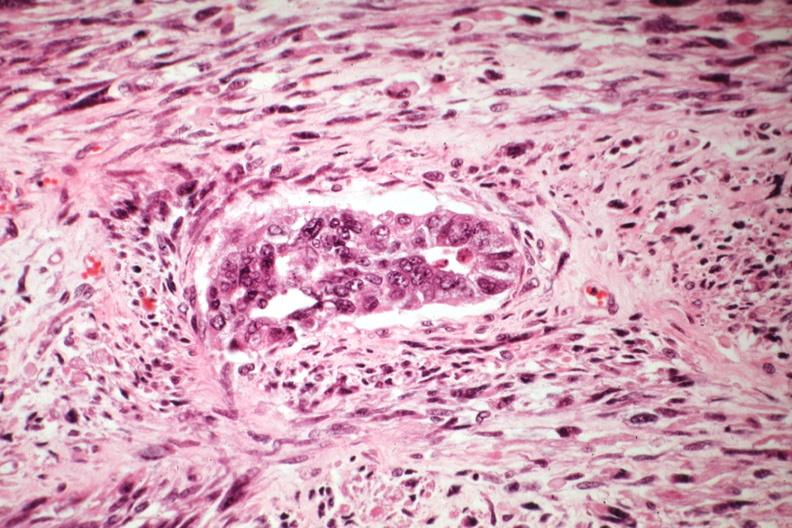what is present?
Answer the question using a single word or phrase. Uterus 